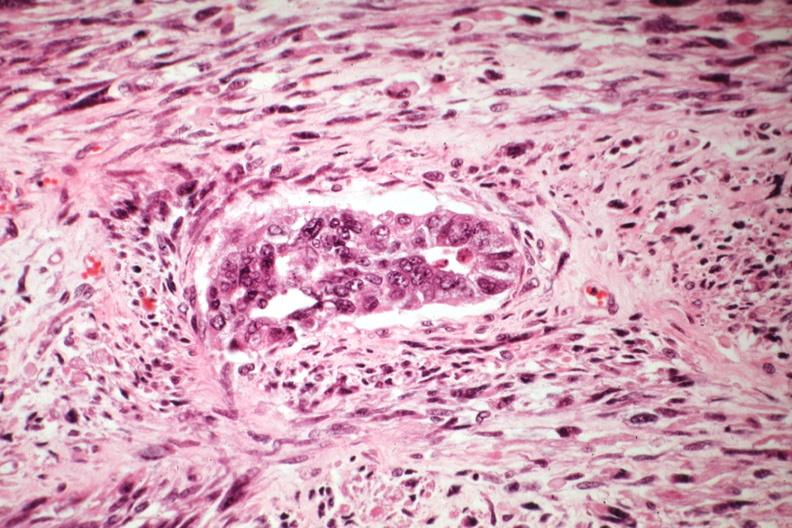what is present?
Answer the question using a single word or phrase. Uterus 